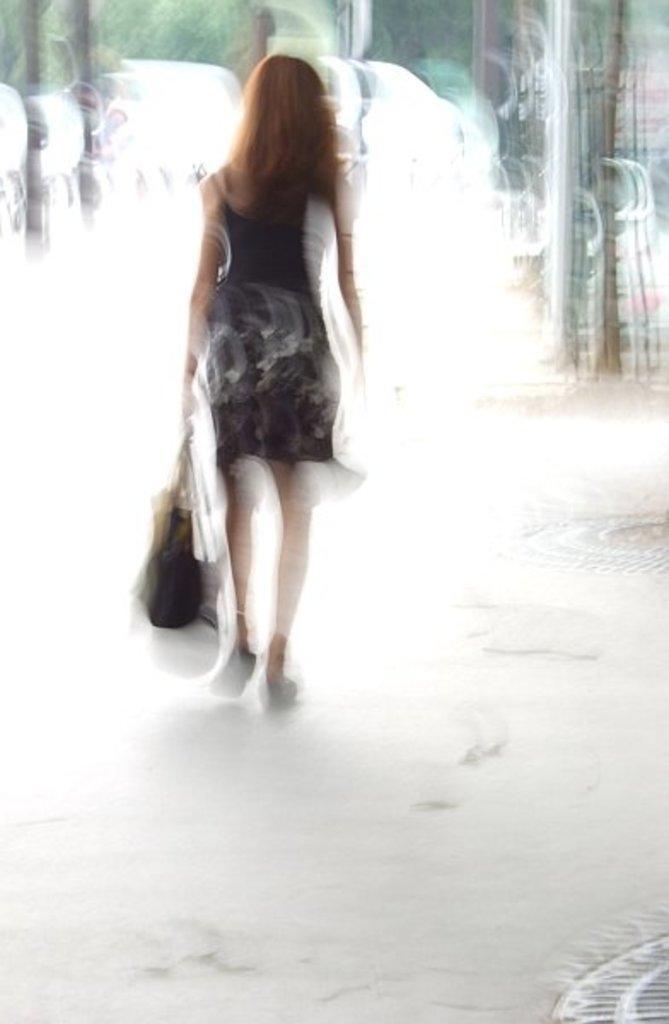Please provide a concise description of this image. This looks like an edited image. Here is the woman holding a bag and walking. The background looks blurry. 